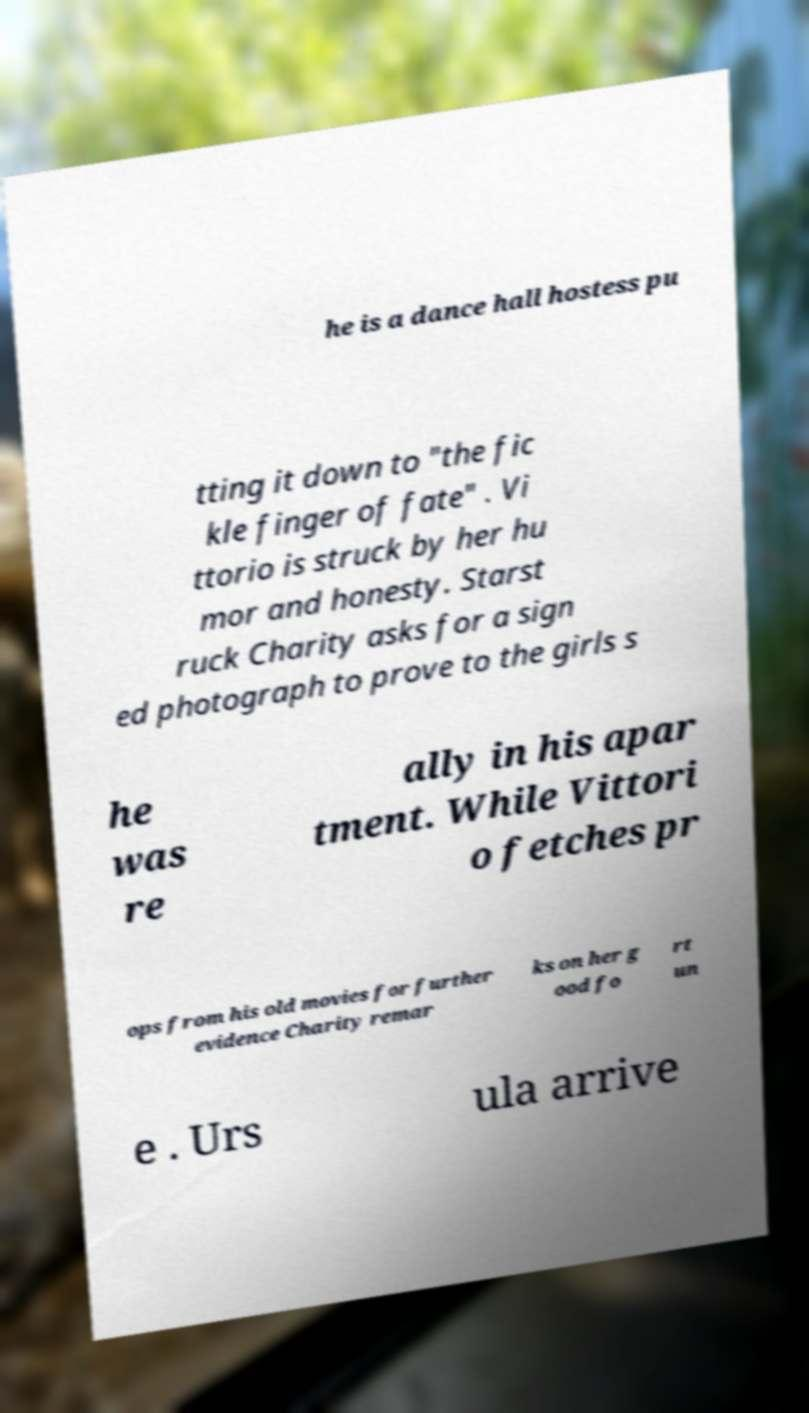There's text embedded in this image that I need extracted. Can you transcribe it verbatim? he is a dance hall hostess pu tting it down to "the fic kle finger of fate" . Vi ttorio is struck by her hu mor and honesty. Starst ruck Charity asks for a sign ed photograph to prove to the girls s he was re ally in his apar tment. While Vittori o fetches pr ops from his old movies for further evidence Charity remar ks on her g ood fo rt un e . Urs ula arrive 